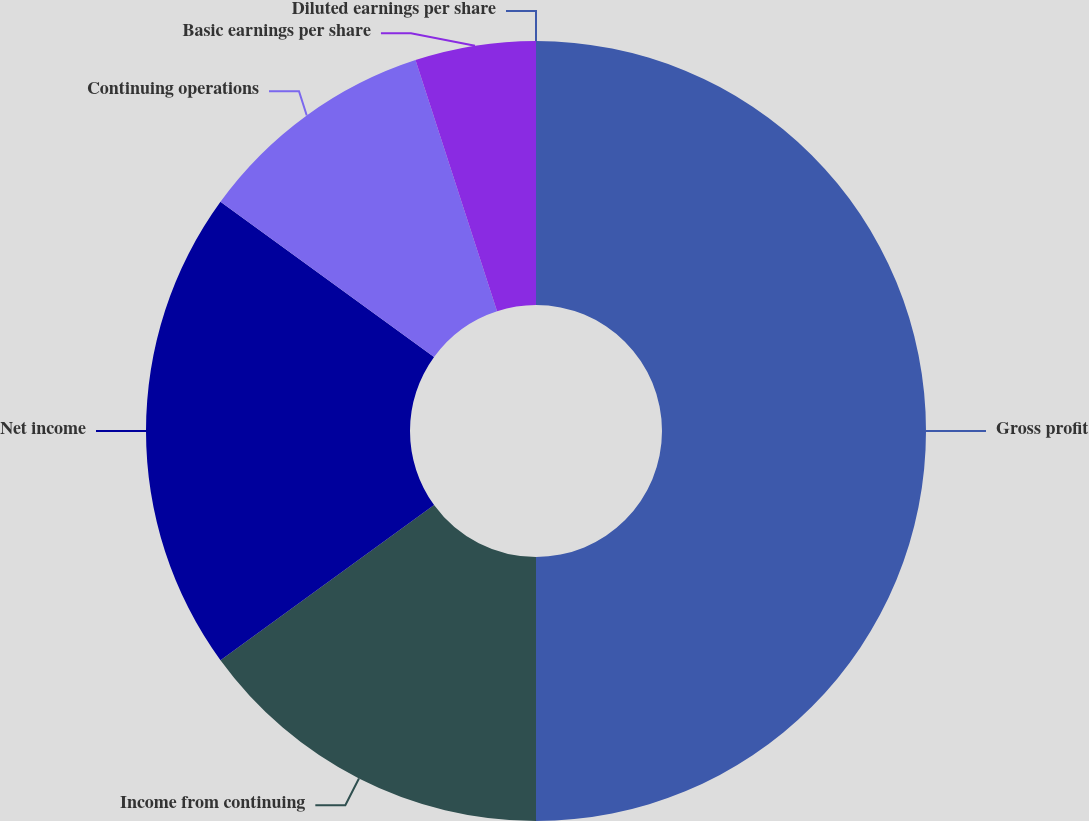<chart> <loc_0><loc_0><loc_500><loc_500><pie_chart><fcel>Gross profit<fcel>Income from continuing<fcel>Net income<fcel>Continuing operations<fcel>Basic earnings per share<fcel>Diluted earnings per share<nl><fcel>50.0%<fcel>15.0%<fcel>20.0%<fcel>10.0%<fcel>5.0%<fcel>0.0%<nl></chart> 